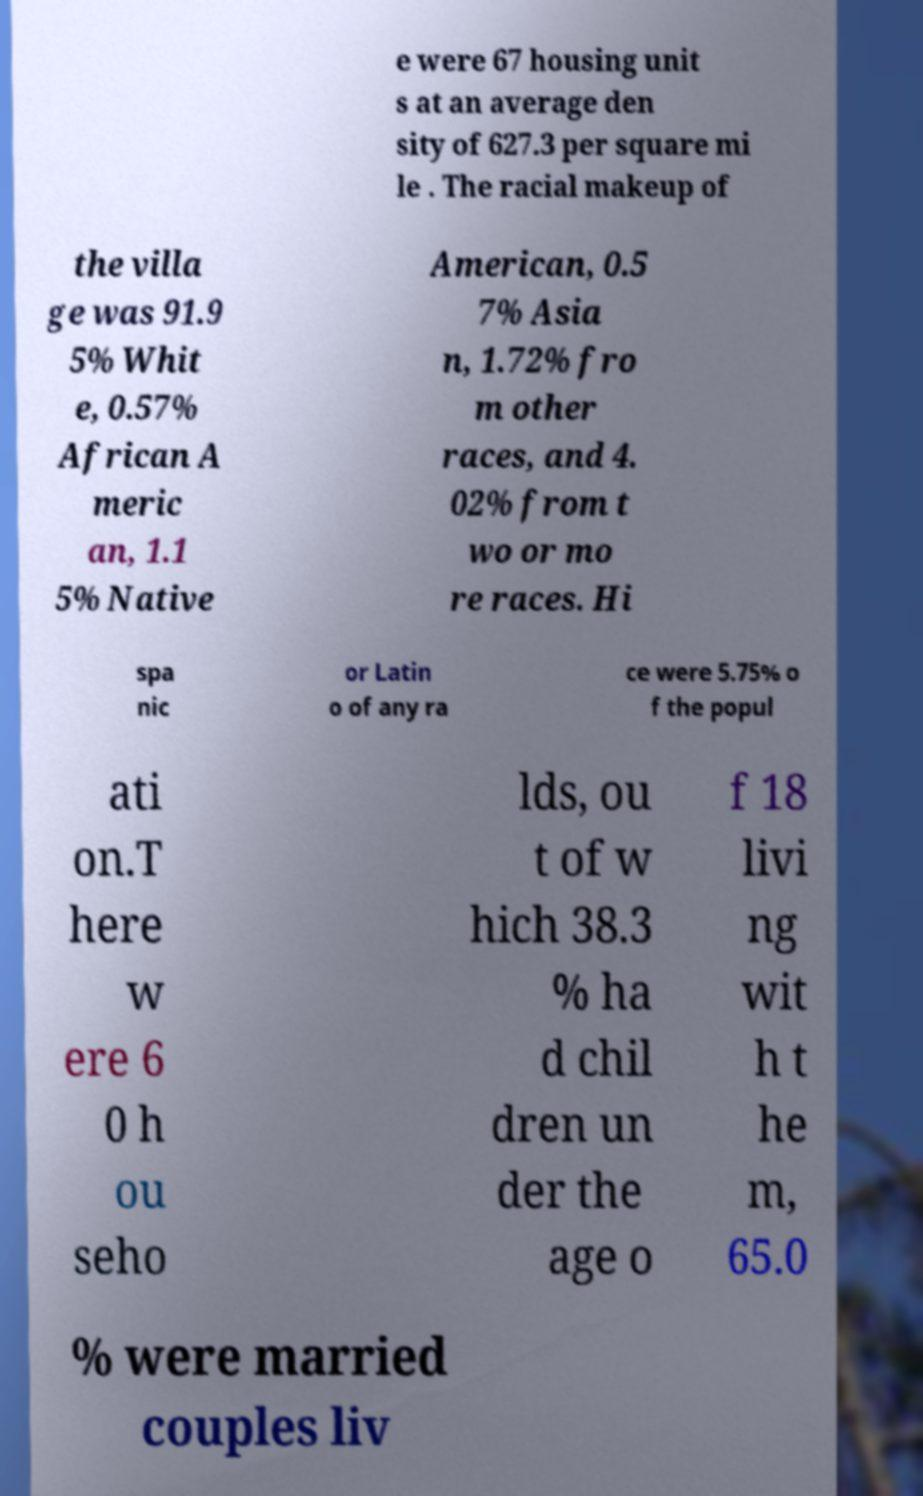Could you extract and type out the text from this image? e were 67 housing unit s at an average den sity of 627.3 per square mi le . The racial makeup of the villa ge was 91.9 5% Whit e, 0.57% African A meric an, 1.1 5% Native American, 0.5 7% Asia n, 1.72% fro m other races, and 4. 02% from t wo or mo re races. Hi spa nic or Latin o of any ra ce were 5.75% o f the popul ati on.T here w ere 6 0 h ou seho lds, ou t of w hich 38.3 % ha d chil dren un der the age o f 18 livi ng wit h t he m, 65.0 % were married couples liv 